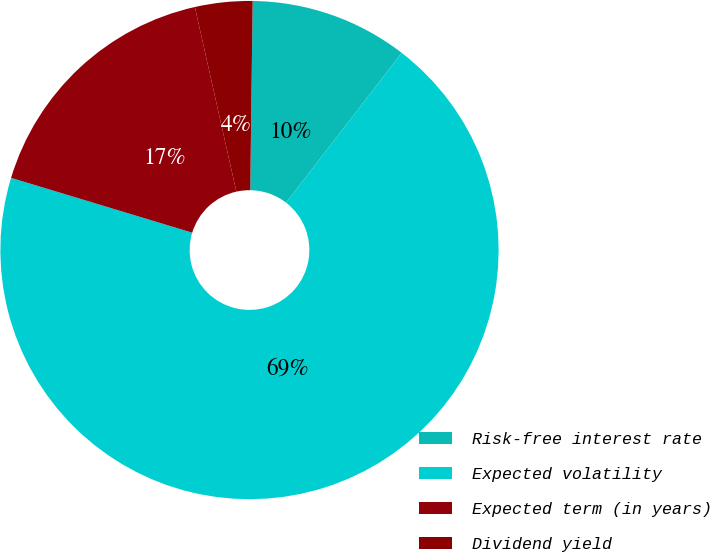<chart> <loc_0><loc_0><loc_500><loc_500><pie_chart><fcel>Risk-free interest rate<fcel>Expected volatility<fcel>Expected term (in years)<fcel>Dividend yield<nl><fcel>10.26%<fcel>69.21%<fcel>16.8%<fcel>3.72%<nl></chart> 